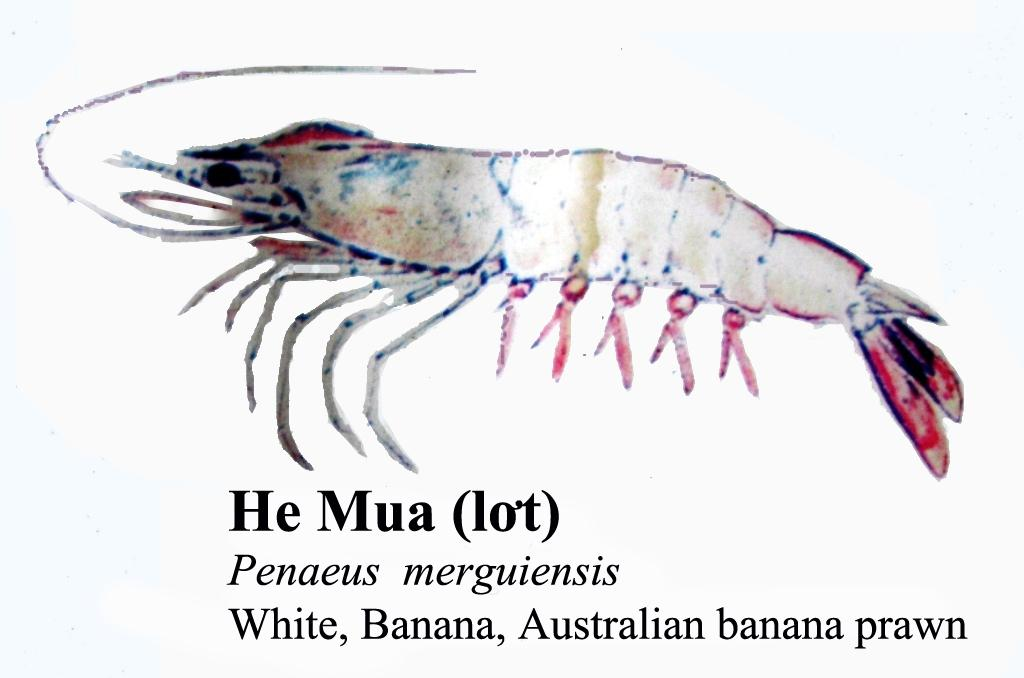What type of creature is present in the image? There is an insect in the image. What colors can be seen on the insect? The insect has cream, red, and black colors. What else is featured in the image besides the insect? There is text written on the image. What is the color of the background in the image? The background of the image is white. What type of birth can be seen taking place in the image? There is no birth taking place in the image; it features an insect with text on a white background. What suggestion is being made by the insect in the image? There is no suggestion being made by the insect in the image; it is simply a static image of an insect with text on a white background. 